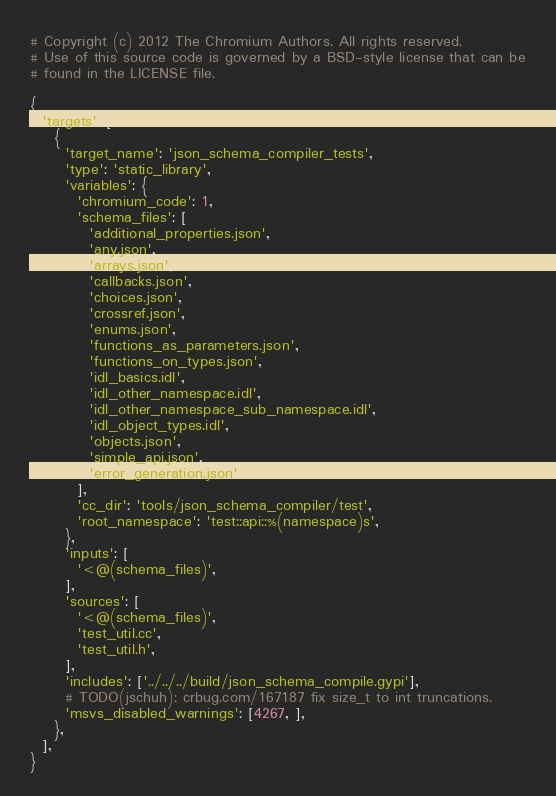Convert code to text. <code><loc_0><loc_0><loc_500><loc_500><_Python_># Copyright (c) 2012 The Chromium Authors. All rights reserved.
# Use of this source code is governed by a BSD-style license that can be
# found in the LICENSE file.

{
  'targets': [
    {
      'target_name': 'json_schema_compiler_tests',
      'type': 'static_library',
      'variables': {
        'chromium_code': 1,
        'schema_files': [
          'additional_properties.json',
          'any.json',
          'arrays.json',
          'callbacks.json',
          'choices.json',
          'crossref.json',
          'enums.json',
          'functions_as_parameters.json',
          'functions_on_types.json',
          'idl_basics.idl',
          'idl_other_namespace.idl',
          'idl_other_namespace_sub_namespace.idl',
          'idl_object_types.idl',
          'objects.json',
          'simple_api.json',
          'error_generation.json'
        ],
        'cc_dir': 'tools/json_schema_compiler/test',
        'root_namespace': 'test::api::%(namespace)s',
      },
      'inputs': [
        '<@(schema_files)',
      ],
      'sources': [
        '<@(schema_files)',
        'test_util.cc',
        'test_util.h',
      ],
      'includes': ['../../../build/json_schema_compile.gypi'],
      # TODO(jschuh): crbug.com/167187 fix size_t to int truncations.
      'msvs_disabled_warnings': [4267, ],
    },
  ],
}
</code> 